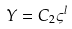<formula> <loc_0><loc_0><loc_500><loc_500>Y = C _ { 2 } \varsigma ^ { l }</formula> 